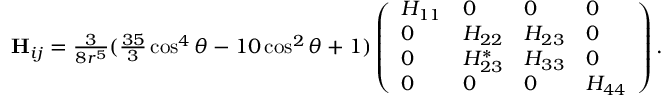Convert formula to latex. <formula><loc_0><loc_0><loc_500><loc_500>\begin{array} { r } { H _ { i j } = \frac { 3 } { 8 r ^ { 5 } } ( \frac { 3 5 } { 3 } \cos ^ { 4 } \theta - 1 0 \cos ^ { 2 } \theta + 1 ) \left ( \begin{array} { l l l l } { H _ { 1 1 } } & { 0 } & { 0 } & { 0 } \\ { 0 } & { H _ { 2 2 } } & { H _ { 2 3 } } & { 0 } \\ { 0 } & { H _ { 2 3 } ^ { * } } & { H _ { 3 3 } } & { 0 } \\ { 0 } & { 0 } & { 0 } & { H _ { 4 4 } } \end{array} \right ) . } \end{array}</formula> 